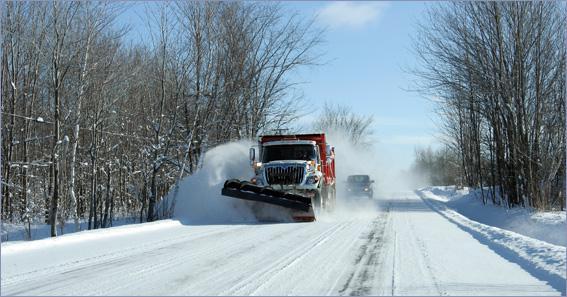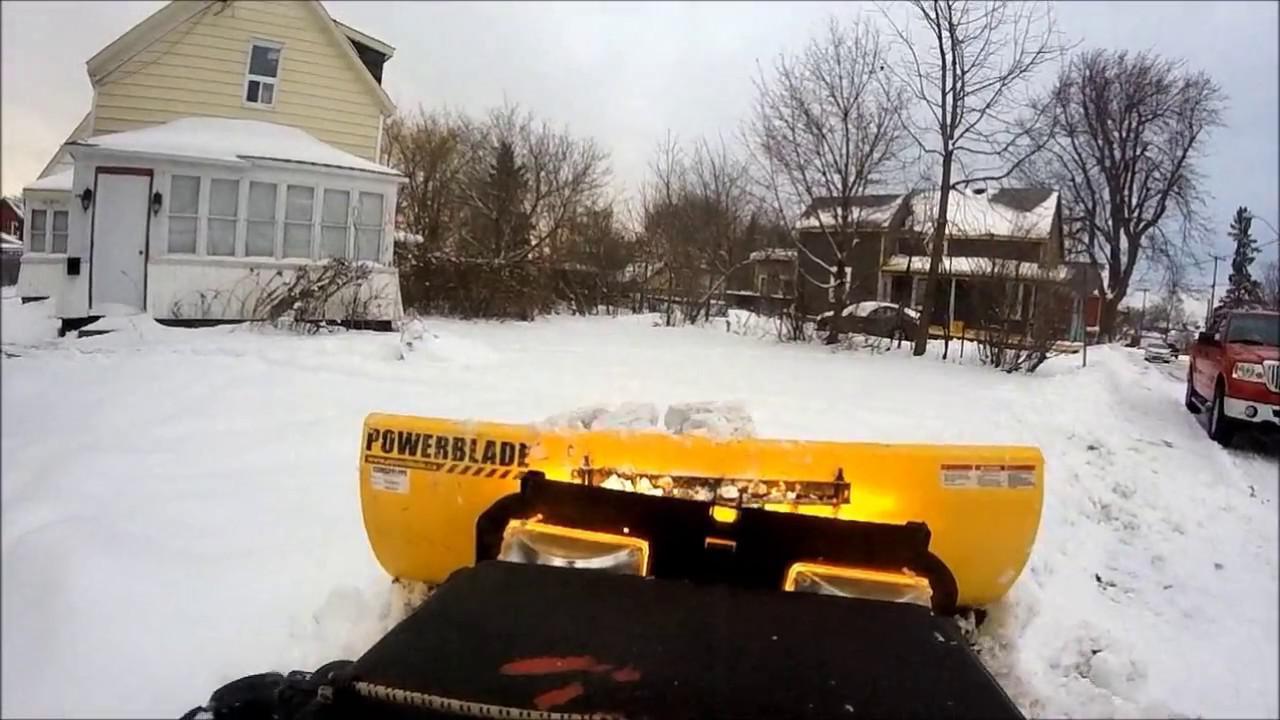The first image is the image on the left, the second image is the image on the right. Assess this claim about the two images: "At least one of the trucks is pushing a yellow plow through the snow.". Correct or not? Answer yes or no. Yes. 